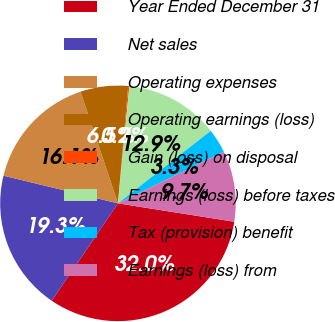Convert chart. <chart><loc_0><loc_0><loc_500><loc_500><pie_chart><fcel>Year Ended December 31<fcel>Net sales<fcel>Operating expenses<fcel>Operating earnings (loss)<fcel>Gain (loss) on disposal<fcel>Earnings (loss) before taxes<fcel>Tax (provision) benefit<fcel>Earnings (loss) from<nl><fcel>32.01%<fcel>19.27%<fcel>16.08%<fcel>6.53%<fcel>0.16%<fcel>12.9%<fcel>3.34%<fcel>9.71%<nl></chart> 